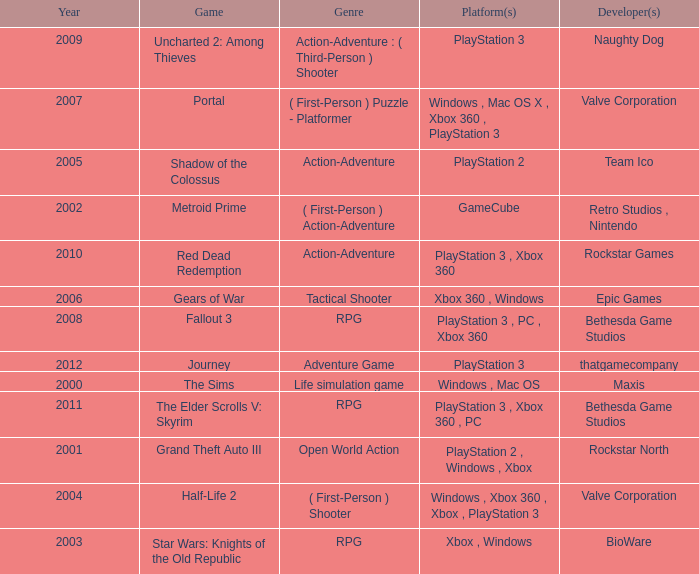What game was in 2001? Grand Theft Auto III. 